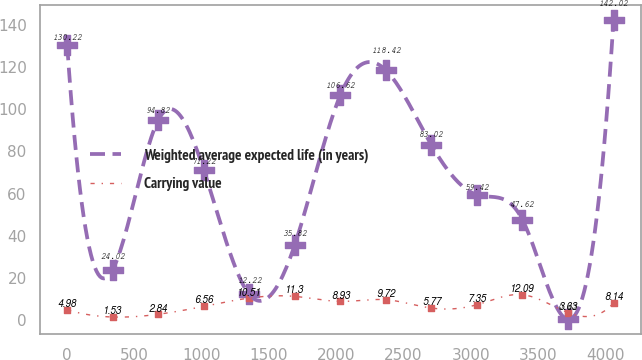Convert chart. <chart><loc_0><loc_0><loc_500><loc_500><line_chart><ecel><fcel>Weighted average expected life (in years)<fcel>Carrying value<nl><fcel>4.77<fcel>130.22<fcel>4.98<nl><fcel>342.63<fcel>24.02<fcel>1.53<nl><fcel>680.49<fcel>94.82<fcel>2.84<nl><fcel>1018.35<fcel>71.22<fcel>6.56<nl><fcel>1356.21<fcel>12.22<fcel>10.51<nl><fcel>1694.07<fcel>35.82<fcel>11.3<nl><fcel>2031.93<fcel>106.62<fcel>8.93<nl><fcel>2369.79<fcel>118.42<fcel>9.72<nl><fcel>2707.65<fcel>83.02<fcel>5.77<nl><fcel>3045.51<fcel>59.42<fcel>7.35<nl><fcel>3383.37<fcel>47.62<fcel>12.09<nl><fcel>3721.23<fcel>0.42<fcel>3.63<nl><fcel>4059.09<fcel>142.02<fcel>8.14<nl></chart> 